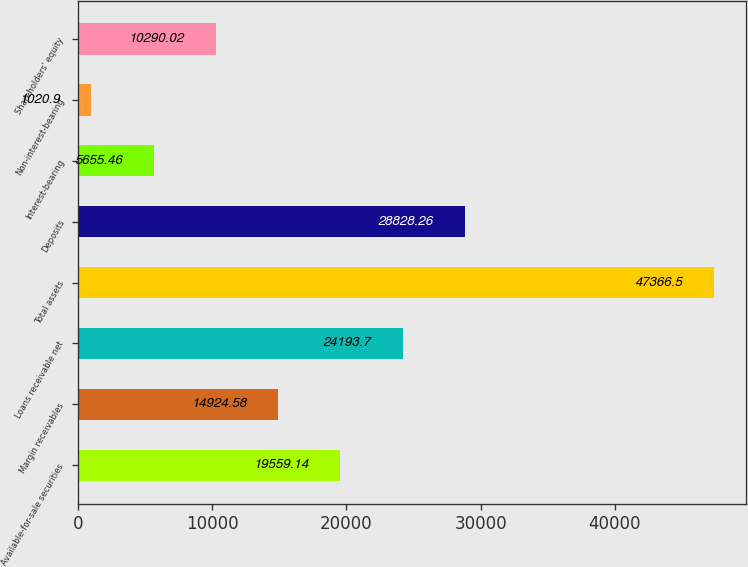Convert chart to OTSL. <chart><loc_0><loc_0><loc_500><loc_500><bar_chart><fcel>Available-for-sale securities<fcel>Margin receivables<fcel>Loans receivable net<fcel>Total assets<fcel>Deposits<fcel>Interest-bearing<fcel>Non-interest-bearing<fcel>Shareholders' equity<nl><fcel>19559.1<fcel>14924.6<fcel>24193.7<fcel>47366.5<fcel>28828.3<fcel>5655.46<fcel>1020.9<fcel>10290<nl></chart> 